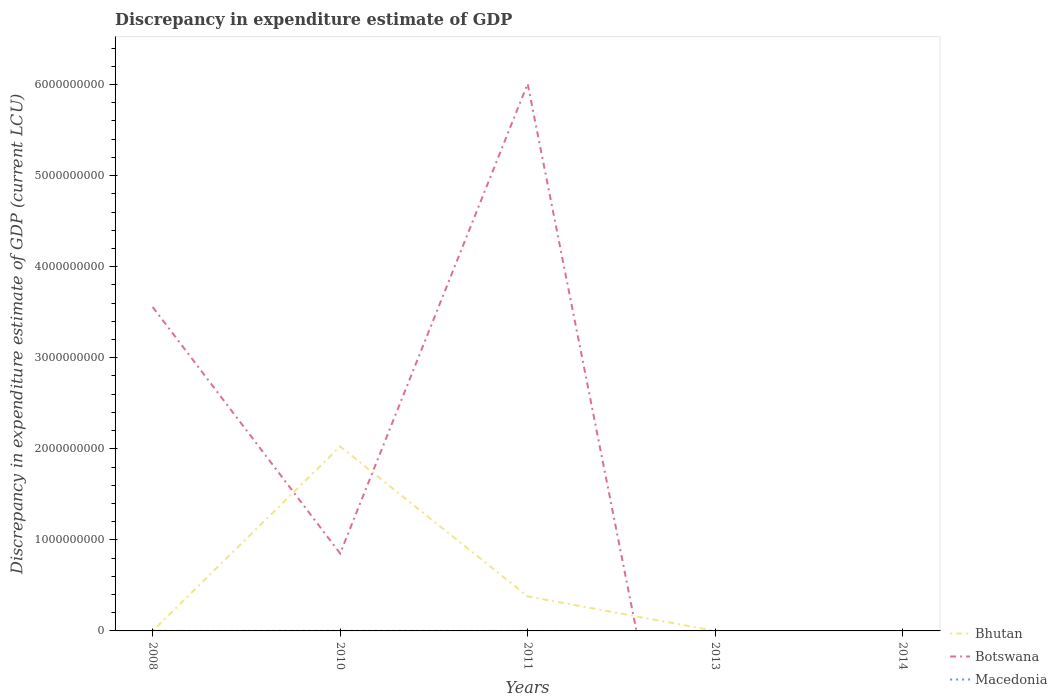How many different coloured lines are there?
Offer a very short reply. 3. Does the line corresponding to Bhutan intersect with the line corresponding to Botswana?
Provide a succinct answer. Yes. Is the number of lines equal to the number of legend labels?
Keep it short and to the point. No. Across all years, what is the maximum discrepancy in expenditure estimate of GDP in Bhutan?
Provide a succinct answer. 2e-6. What is the difference between the highest and the second highest discrepancy in expenditure estimate of GDP in Bhutan?
Provide a succinct answer. 2.03e+09. Is the discrepancy in expenditure estimate of GDP in Bhutan strictly greater than the discrepancy in expenditure estimate of GDP in Macedonia over the years?
Give a very brief answer. No. Does the graph contain any zero values?
Ensure brevity in your answer.  Yes. How are the legend labels stacked?
Your answer should be very brief. Vertical. What is the title of the graph?
Keep it short and to the point. Discrepancy in expenditure estimate of GDP. Does "Guinea" appear as one of the legend labels in the graph?
Your answer should be compact. No. What is the label or title of the Y-axis?
Provide a succinct answer. Discrepancy in expenditure estimate of GDP (current LCU). What is the Discrepancy in expenditure estimate of GDP (current LCU) in Bhutan in 2008?
Make the answer very short. 2e-6. What is the Discrepancy in expenditure estimate of GDP (current LCU) in Botswana in 2008?
Provide a short and direct response. 3.56e+09. What is the Discrepancy in expenditure estimate of GDP (current LCU) in Macedonia in 2008?
Keep it short and to the point. 6e-5. What is the Discrepancy in expenditure estimate of GDP (current LCU) of Bhutan in 2010?
Provide a short and direct response. 2.03e+09. What is the Discrepancy in expenditure estimate of GDP (current LCU) of Botswana in 2010?
Provide a short and direct response. 8.51e+08. What is the Discrepancy in expenditure estimate of GDP (current LCU) of Bhutan in 2011?
Provide a succinct answer. 3.79e+08. What is the Discrepancy in expenditure estimate of GDP (current LCU) of Botswana in 2011?
Offer a very short reply. 6.01e+09. What is the Discrepancy in expenditure estimate of GDP (current LCU) of Macedonia in 2011?
Your answer should be compact. 6e-5. What is the Discrepancy in expenditure estimate of GDP (current LCU) of Botswana in 2013?
Keep it short and to the point. 0. What is the Discrepancy in expenditure estimate of GDP (current LCU) in Macedonia in 2013?
Offer a very short reply. 0. What is the Discrepancy in expenditure estimate of GDP (current LCU) of Bhutan in 2014?
Your answer should be very brief. 4.00e+04. What is the Discrepancy in expenditure estimate of GDP (current LCU) of Botswana in 2014?
Your answer should be compact. 0. What is the Discrepancy in expenditure estimate of GDP (current LCU) of Macedonia in 2014?
Ensure brevity in your answer.  0. Across all years, what is the maximum Discrepancy in expenditure estimate of GDP (current LCU) in Bhutan?
Offer a very short reply. 2.03e+09. Across all years, what is the maximum Discrepancy in expenditure estimate of GDP (current LCU) of Botswana?
Keep it short and to the point. 6.01e+09. Across all years, what is the maximum Discrepancy in expenditure estimate of GDP (current LCU) of Macedonia?
Ensure brevity in your answer.  1.00e+06. Across all years, what is the minimum Discrepancy in expenditure estimate of GDP (current LCU) of Bhutan?
Offer a terse response. 2e-6. Across all years, what is the minimum Discrepancy in expenditure estimate of GDP (current LCU) of Botswana?
Keep it short and to the point. 0. Across all years, what is the minimum Discrepancy in expenditure estimate of GDP (current LCU) of Macedonia?
Your response must be concise. 0. What is the total Discrepancy in expenditure estimate of GDP (current LCU) in Bhutan in the graph?
Your answer should be very brief. 2.41e+09. What is the total Discrepancy in expenditure estimate of GDP (current LCU) in Botswana in the graph?
Offer a terse response. 1.04e+1. What is the total Discrepancy in expenditure estimate of GDP (current LCU) in Macedonia in the graph?
Offer a very short reply. 1.00e+06. What is the difference between the Discrepancy in expenditure estimate of GDP (current LCU) of Bhutan in 2008 and that in 2010?
Your answer should be compact. -2.03e+09. What is the difference between the Discrepancy in expenditure estimate of GDP (current LCU) of Botswana in 2008 and that in 2010?
Your answer should be compact. 2.71e+09. What is the difference between the Discrepancy in expenditure estimate of GDP (current LCU) in Macedonia in 2008 and that in 2010?
Your answer should be compact. -1.00e+06. What is the difference between the Discrepancy in expenditure estimate of GDP (current LCU) in Bhutan in 2008 and that in 2011?
Your answer should be compact. -3.79e+08. What is the difference between the Discrepancy in expenditure estimate of GDP (current LCU) in Botswana in 2008 and that in 2011?
Your answer should be compact. -2.45e+09. What is the difference between the Discrepancy in expenditure estimate of GDP (current LCU) of Bhutan in 2008 and that in 2013?
Offer a terse response. -4.00e+05. What is the difference between the Discrepancy in expenditure estimate of GDP (current LCU) of Bhutan in 2010 and that in 2011?
Make the answer very short. 1.65e+09. What is the difference between the Discrepancy in expenditure estimate of GDP (current LCU) in Botswana in 2010 and that in 2011?
Make the answer very short. -5.16e+09. What is the difference between the Discrepancy in expenditure estimate of GDP (current LCU) of Macedonia in 2010 and that in 2011?
Ensure brevity in your answer.  1.00e+06. What is the difference between the Discrepancy in expenditure estimate of GDP (current LCU) in Bhutan in 2010 and that in 2013?
Ensure brevity in your answer.  2.03e+09. What is the difference between the Discrepancy in expenditure estimate of GDP (current LCU) in Bhutan in 2010 and that in 2014?
Keep it short and to the point. 2.03e+09. What is the difference between the Discrepancy in expenditure estimate of GDP (current LCU) of Bhutan in 2011 and that in 2013?
Provide a succinct answer. 3.79e+08. What is the difference between the Discrepancy in expenditure estimate of GDP (current LCU) in Bhutan in 2011 and that in 2014?
Make the answer very short. 3.79e+08. What is the difference between the Discrepancy in expenditure estimate of GDP (current LCU) of Bhutan in 2008 and the Discrepancy in expenditure estimate of GDP (current LCU) of Botswana in 2010?
Your response must be concise. -8.51e+08. What is the difference between the Discrepancy in expenditure estimate of GDP (current LCU) in Botswana in 2008 and the Discrepancy in expenditure estimate of GDP (current LCU) in Macedonia in 2010?
Make the answer very short. 3.56e+09. What is the difference between the Discrepancy in expenditure estimate of GDP (current LCU) in Bhutan in 2008 and the Discrepancy in expenditure estimate of GDP (current LCU) in Botswana in 2011?
Your response must be concise. -6.01e+09. What is the difference between the Discrepancy in expenditure estimate of GDP (current LCU) of Bhutan in 2008 and the Discrepancy in expenditure estimate of GDP (current LCU) of Macedonia in 2011?
Your response must be concise. -0. What is the difference between the Discrepancy in expenditure estimate of GDP (current LCU) in Botswana in 2008 and the Discrepancy in expenditure estimate of GDP (current LCU) in Macedonia in 2011?
Offer a terse response. 3.56e+09. What is the difference between the Discrepancy in expenditure estimate of GDP (current LCU) of Bhutan in 2010 and the Discrepancy in expenditure estimate of GDP (current LCU) of Botswana in 2011?
Give a very brief answer. -3.98e+09. What is the difference between the Discrepancy in expenditure estimate of GDP (current LCU) of Bhutan in 2010 and the Discrepancy in expenditure estimate of GDP (current LCU) of Macedonia in 2011?
Provide a short and direct response. 2.03e+09. What is the difference between the Discrepancy in expenditure estimate of GDP (current LCU) of Botswana in 2010 and the Discrepancy in expenditure estimate of GDP (current LCU) of Macedonia in 2011?
Your response must be concise. 8.51e+08. What is the average Discrepancy in expenditure estimate of GDP (current LCU) of Bhutan per year?
Offer a very short reply. 4.81e+08. What is the average Discrepancy in expenditure estimate of GDP (current LCU) of Botswana per year?
Provide a short and direct response. 2.08e+09. What is the average Discrepancy in expenditure estimate of GDP (current LCU) in Macedonia per year?
Your answer should be very brief. 2.00e+05. In the year 2008, what is the difference between the Discrepancy in expenditure estimate of GDP (current LCU) of Bhutan and Discrepancy in expenditure estimate of GDP (current LCU) of Botswana?
Provide a short and direct response. -3.56e+09. In the year 2008, what is the difference between the Discrepancy in expenditure estimate of GDP (current LCU) of Bhutan and Discrepancy in expenditure estimate of GDP (current LCU) of Macedonia?
Your answer should be compact. -0. In the year 2008, what is the difference between the Discrepancy in expenditure estimate of GDP (current LCU) in Botswana and Discrepancy in expenditure estimate of GDP (current LCU) in Macedonia?
Offer a terse response. 3.56e+09. In the year 2010, what is the difference between the Discrepancy in expenditure estimate of GDP (current LCU) of Bhutan and Discrepancy in expenditure estimate of GDP (current LCU) of Botswana?
Your response must be concise. 1.18e+09. In the year 2010, what is the difference between the Discrepancy in expenditure estimate of GDP (current LCU) in Bhutan and Discrepancy in expenditure estimate of GDP (current LCU) in Macedonia?
Provide a succinct answer. 2.02e+09. In the year 2010, what is the difference between the Discrepancy in expenditure estimate of GDP (current LCU) in Botswana and Discrepancy in expenditure estimate of GDP (current LCU) in Macedonia?
Make the answer very short. 8.50e+08. In the year 2011, what is the difference between the Discrepancy in expenditure estimate of GDP (current LCU) of Bhutan and Discrepancy in expenditure estimate of GDP (current LCU) of Botswana?
Make the answer very short. -5.63e+09. In the year 2011, what is the difference between the Discrepancy in expenditure estimate of GDP (current LCU) in Bhutan and Discrepancy in expenditure estimate of GDP (current LCU) in Macedonia?
Your response must be concise. 3.79e+08. In the year 2011, what is the difference between the Discrepancy in expenditure estimate of GDP (current LCU) in Botswana and Discrepancy in expenditure estimate of GDP (current LCU) in Macedonia?
Provide a short and direct response. 6.01e+09. What is the ratio of the Discrepancy in expenditure estimate of GDP (current LCU) in Botswana in 2008 to that in 2010?
Your answer should be very brief. 4.18. What is the ratio of the Discrepancy in expenditure estimate of GDP (current LCU) of Macedonia in 2008 to that in 2010?
Offer a very short reply. 0. What is the ratio of the Discrepancy in expenditure estimate of GDP (current LCU) in Botswana in 2008 to that in 2011?
Provide a succinct answer. 0.59. What is the ratio of the Discrepancy in expenditure estimate of GDP (current LCU) in Bhutan in 2008 to that in 2013?
Provide a succinct answer. 0. What is the ratio of the Discrepancy in expenditure estimate of GDP (current LCU) of Bhutan in 2010 to that in 2011?
Keep it short and to the point. 5.34. What is the ratio of the Discrepancy in expenditure estimate of GDP (current LCU) of Botswana in 2010 to that in 2011?
Your answer should be compact. 0.14. What is the ratio of the Discrepancy in expenditure estimate of GDP (current LCU) in Macedonia in 2010 to that in 2011?
Your answer should be compact. 1.67e+1. What is the ratio of the Discrepancy in expenditure estimate of GDP (current LCU) in Bhutan in 2010 to that in 2013?
Your response must be concise. 5064.6. What is the ratio of the Discrepancy in expenditure estimate of GDP (current LCU) in Bhutan in 2010 to that in 2014?
Your response must be concise. 5.06e+04. What is the ratio of the Discrepancy in expenditure estimate of GDP (current LCU) in Bhutan in 2011 to that in 2013?
Your answer should be very brief. 948.09. What is the ratio of the Discrepancy in expenditure estimate of GDP (current LCU) of Bhutan in 2011 to that in 2014?
Give a very brief answer. 9480.86. What is the difference between the highest and the second highest Discrepancy in expenditure estimate of GDP (current LCU) of Bhutan?
Provide a short and direct response. 1.65e+09. What is the difference between the highest and the second highest Discrepancy in expenditure estimate of GDP (current LCU) of Botswana?
Your answer should be very brief. 2.45e+09. What is the difference between the highest and the second highest Discrepancy in expenditure estimate of GDP (current LCU) in Macedonia?
Keep it short and to the point. 1.00e+06. What is the difference between the highest and the lowest Discrepancy in expenditure estimate of GDP (current LCU) of Bhutan?
Your response must be concise. 2.03e+09. What is the difference between the highest and the lowest Discrepancy in expenditure estimate of GDP (current LCU) of Botswana?
Your response must be concise. 6.01e+09. What is the difference between the highest and the lowest Discrepancy in expenditure estimate of GDP (current LCU) of Macedonia?
Give a very brief answer. 1.00e+06. 